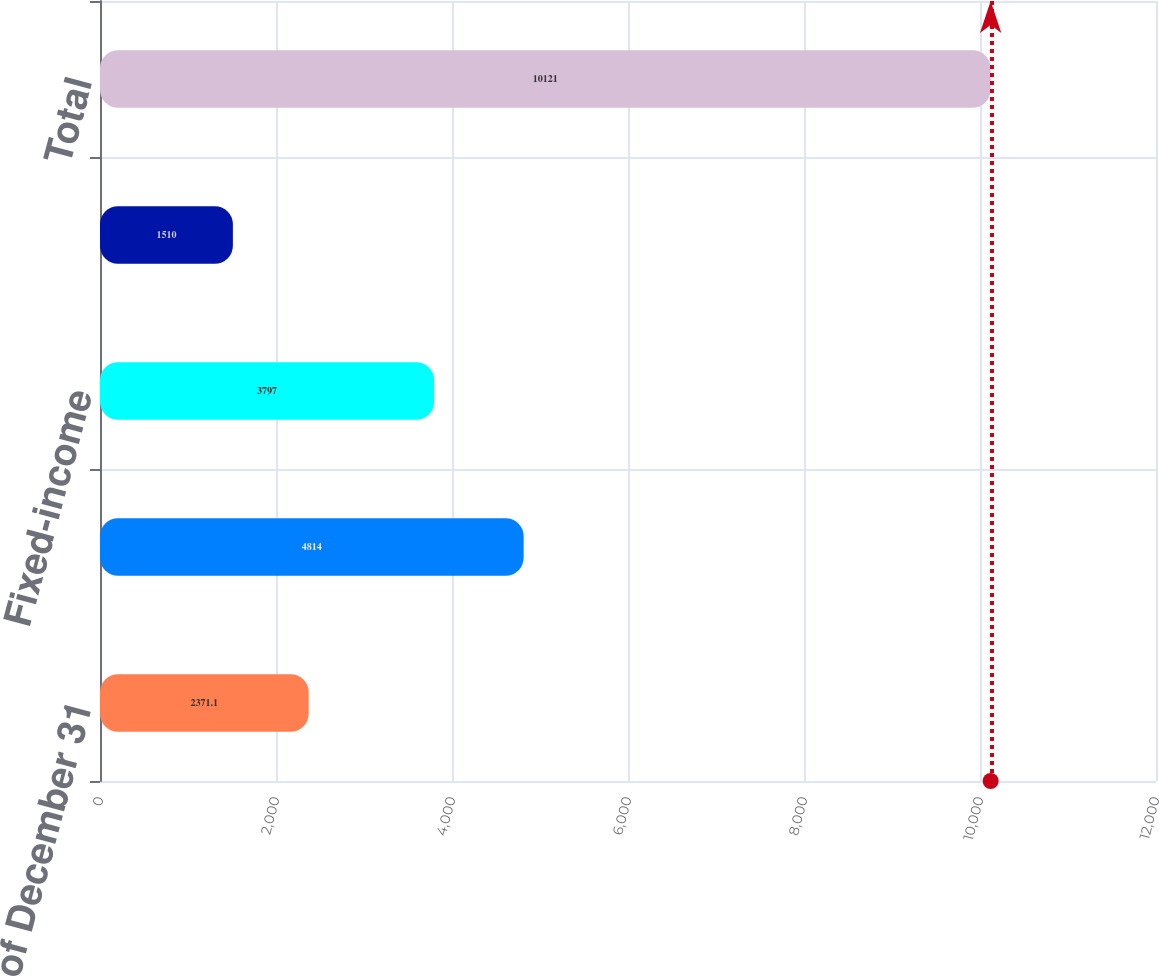Convert chart to OTSL. <chart><loc_0><loc_0><loc_500><loc_500><bar_chart><fcel>As of December 31<fcel>Equities<fcel>Fixed-income<fcel>Short-term and other<fcel>Total<nl><fcel>2371.1<fcel>4814<fcel>3797<fcel>1510<fcel>10121<nl></chart> 